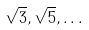Convert formula to latex. <formula><loc_0><loc_0><loc_500><loc_500>\sqrt { 3 } , \sqrt { 5 } , \dots</formula> 